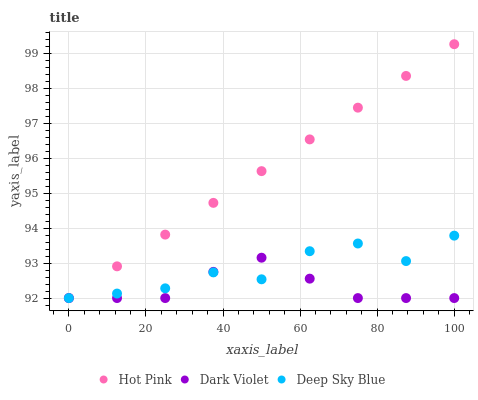Does Dark Violet have the minimum area under the curve?
Answer yes or no. Yes. Does Hot Pink have the maximum area under the curve?
Answer yes or no. Yes. Does Deep Sky Blue have the minimum area under the curve?
Answer yes or no. No. Does Deep Sky Blue have the maximum area under the curve?
Answer yes or no. No. Is Hot Pink the smoothest?
Answer yes or no. Yes. Is Deep Sky Blue the roughest?
Answer yes or no. Yes. Is Dark Violet the smoothest?
Answer yes or no. No. Is Dark Violet the roughest?
Answer yes or no. No. Does Hot Pink have the lowest value?
Answer yes or no. Yes. Does Hot Pink have the highest value?
Answer yes or no. Yes. Does Deep Sky Blue have the highest value?
Answer yes or no. No. Does Dark Violet intersect Deep Sky Blue?
Answer yes or no. Yes. Is Dark Violet less than Deep Sky Blue?
Answer yes or no. No. Is Dark Violet greater than Deep Sky Blue?
Answer yes or no. No. 